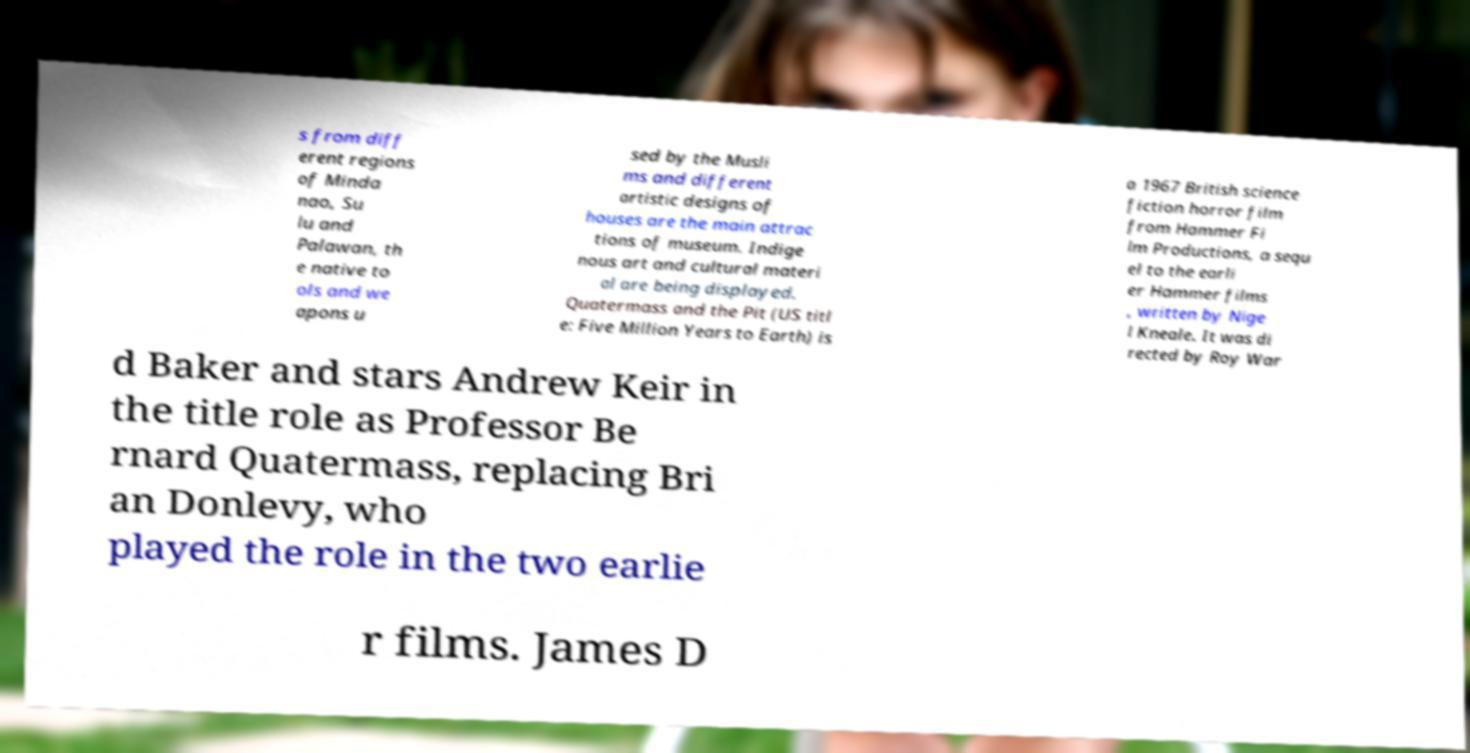Can you accurately transcribe the text from the provided image for me? s from diff erent regions of Minda nao, Su lu and Palawan, th e native to ols and we apons u sed by the Musli ms and different artistic designs of houses are the main attrac tions of museum. Indige nous art and cultural materi al are being displayed. Quatermass and the Pit (US titl e: Five Million Years to Earth) is a 1967 British science fiction horror film from Hammer Fi lm Productions, a sequ el to the earli er Hammer films , written by Nige l Kneale. It was di rected by Roy War d Baker and stars Andrew Keir in the title role as Professor Be rnard Quatermass, replacing Bri an Donlevy, who played the role in the two earlie r films. James D 